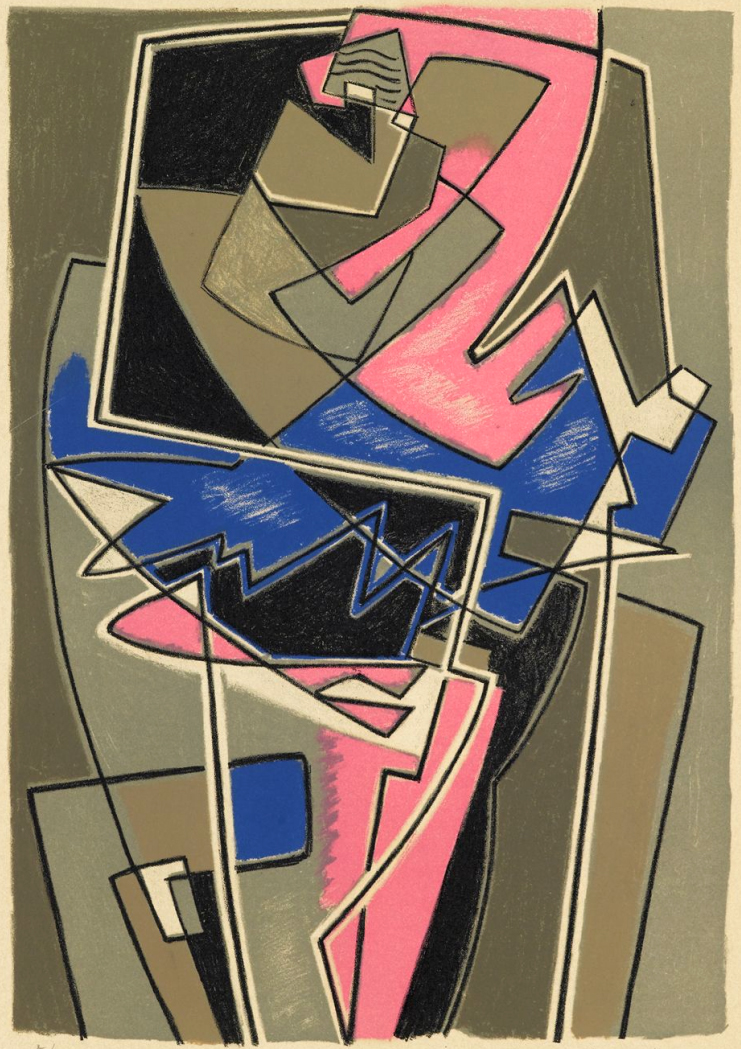What do you think is going on in this snapshot? This image is a striking example of cubism, an art movement noted for its abstract use of geometric forms. The canvas portrays an array of sharply defined shapes and colors that intersect and overlap, creating a vibrant dynamic within the work. Colors like black, gray, pink, and blue punctuate the composition, providing visual depth and emphasis. While this piece abstracts from reality, its geometric precision and the bold juxtaposition of color suggest a break from traditional perspectives, pushing viewers to engage with the art in a more introspective manner. 